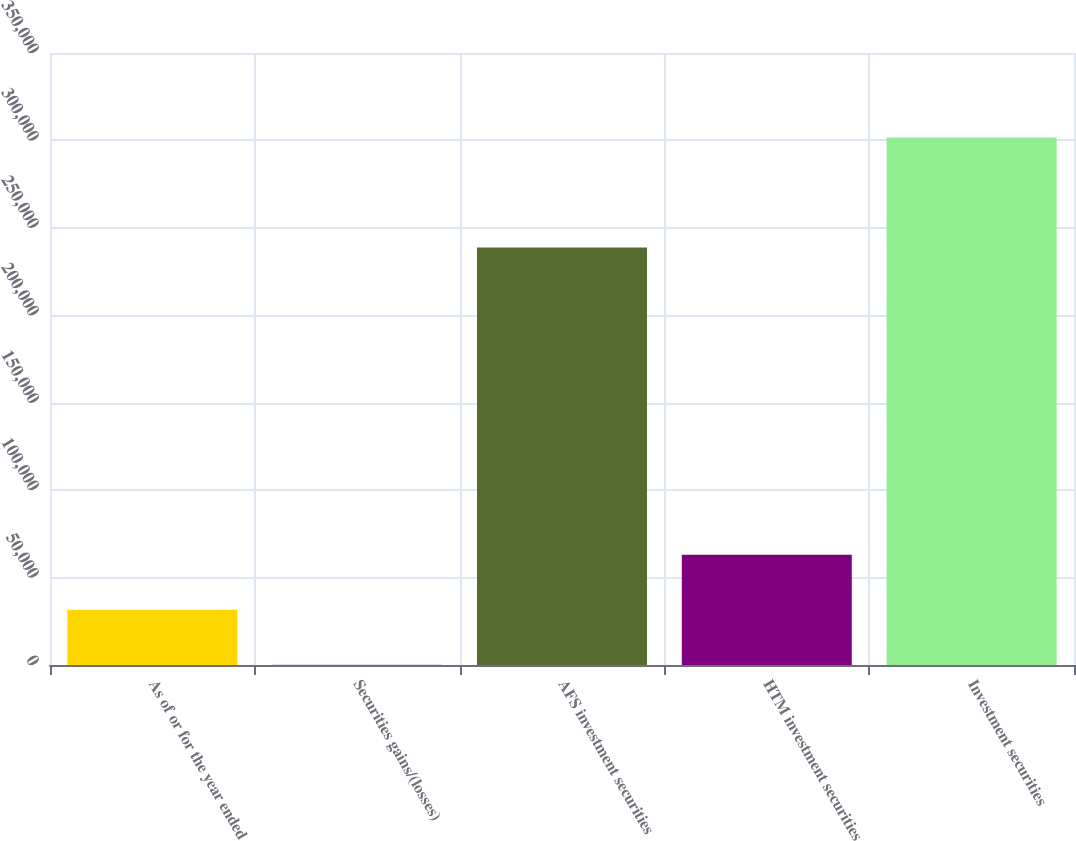Convert chart to OTSL. <chart><loc_0><loc_0><loc_500><loc_500><bar_chart><fcel>As of or for the year ended<fcel>Securities gains/(losses)<fcel>AFS investment securities<fcel>HTM investment securities<fcel>Investment securities<nl><fcel>31651.2<fcel>190<fcel>238704<fcel>63112.4<fcel>301626<nl></chart> 